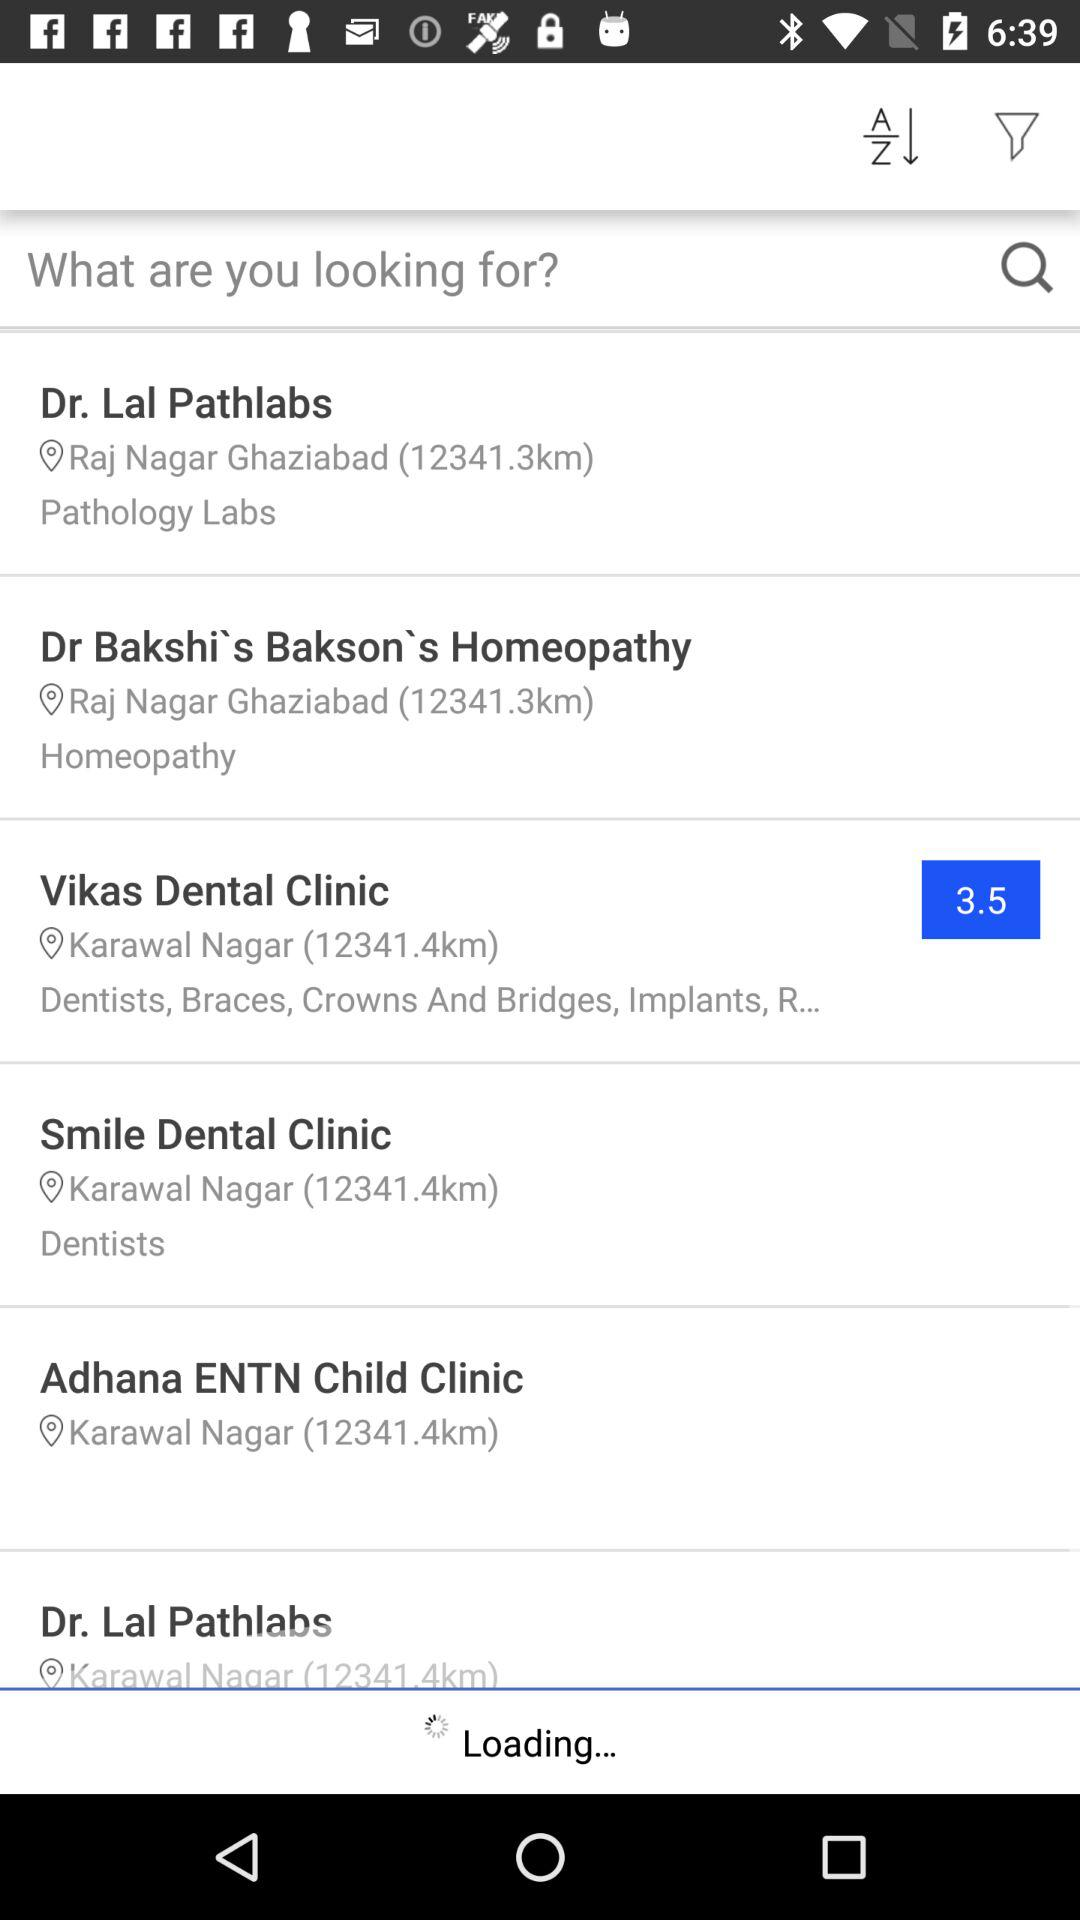What is the rating for "Vikas Dental Clinic"? The rating is 3.5. 